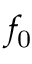Convert formula to latex. <formula><loc_0><loc_0><loc_500><loc_500>f _ { 0 }</formula> 